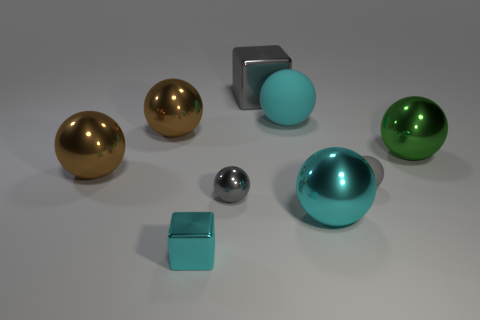The matte ball behind the big green object that is to the right of the shiny cube that is behind the big cyan matte sphere is what color?
Provide a short and direct response. Cyan. What is the size of the shiny cube that is in front of the tiny metallic thing that is behind the small cyan metallic object?
Offer a terse response. Small. What is the gray object that is right of the gray metallic ball and in front of the large matte object made of?
Offer a terse response. Rubber. There is a green thing; does it have the same size as the gray ball to the right of the gray metal block?
Ensure brevity in your answer.  No. Are any spheres visible?
Make the answer very short. Yes. What is the material of the other cyan thing that is the same shape as the big cyan metallic thing?
Your response must be concise. Rubber. How big is the cube that is behind the cyan shiny object on the right side of the shiny cube that is behind the tiny cyan metal cube?
Your answer should be compact. Large. Are there any gray metal things left of the gray rubber ball?
Keep it short and to the point. Yes. There is a green sphere that is made of the same material as the large block; what size is it?
Provide a succinct answer. Large. How many big metal objects have the same shape as the small cyan thing?
Your answer should be compact. 1. 